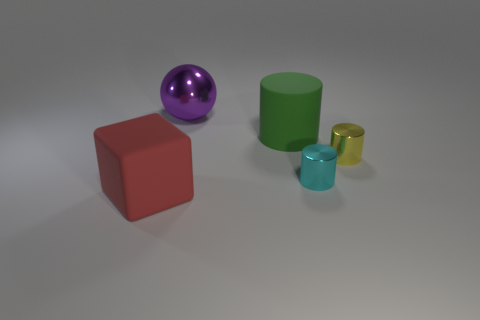Subtract all green matte cylinders. How many cylinders are left? 2 Add 1 cylinders. How many objects exist? 6 Subtract all yellow cylinders. How many cylinders are left? 2 Subtract all cylinders. How many objects are left? 2 Subtract 1 cylinders. How many cylinders are left? 2 Subtract all green spheres. How many purple cylinders are left? 0 Subtract all big red rubber things. Subtract all metal cylinders. How many objects are left? 2 Add 1 metal objects. How many metal objects are left? 4 Add 2 tiny brown matte balls. How many tiny brown matte balls exist? 2 Subtract 1 red cubes. How many objects are left? 4 